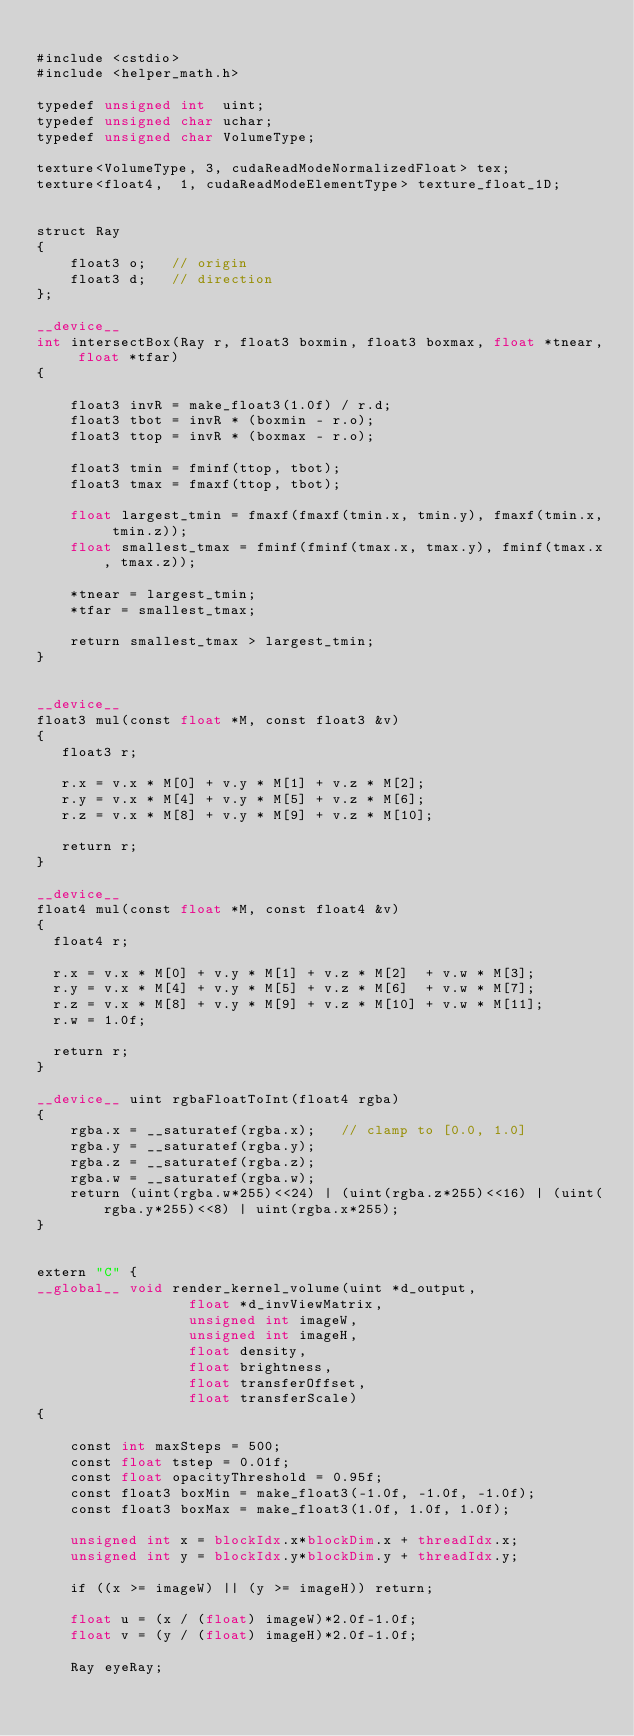Convert code to text. <code><loc_0><loc_0><loc_500><loc_500><_Cuda_>
#include <cstdio>
#include <helper_math.h>

typedef unsigned int  uint;
typedef unsigned char uchar;
typedef unsigned char VolumeType;

texture<VolumeType, 3, cudaReadModeNormalizedFloat> tex;    
texture<float4,  1, cudaReadModeElementType> texture_float_1D;


struct Ray
{
    float3 o;   // origin
    float3 d;   // direction
};

__device__
int intersectBox(Ray r, float3 boxmin, float3 boxmax, float *tnear, float *tfar)
{

    float3 invR = make_float3(1.0f) / r.d;
    float3 tbot = invR * (boxmin - r.o);
    float3 ttop = invR * (boxmax - r.o);

    float3 tmin = fminf(ttop, tbot);
    float3 tmax = fmaxf(ttop, tbot);

    float largest_tmin = fmaxf(fmaxf(tmin.x, tmin.y), fmaxf(tmin.x, tmin.z));
    float smallest_tmax = fminf(fminf(tmax.x, tmax.y), fminf(tmax.x, tmax.z));

    *tnear = largest_tmin;
    *tfar = smallest_tmax;

    return smallest_tmax > largest_tmin;
}


__device__
float3 mul(const float *M, const float3 &v)
{
   float3 r;
   
   r.x = v.x * M[0] + v.y * M[1] + v.z * M[2];
   r.y = v.x * M[4] + v.y * M[5] + v.z * M[6];
   r.z = v.x * M[8] + v.y * M[9] + v.z * M[10];
   
   return r;
}

__device__
float4 mul(const float *M, const float4 &v)
{
	float4 r;

	r.x = v.x * M[0] + v.y * M[1] + v.z * M[2]  + v.w * M[3];
	r.y = v.x * M[4] + v.y * M[5] + v.z * M[6]  + v.w * M[7];
	r.z = v.x * M[8] + v.y * M[9] + v.z * M[10] + v.w * M[11];	
	r.w = 1.0f;
	
	return r;
}

__device__ uint rgbaFloatToInt(float4 rgba)
{
    rgba.x = __saturatef(rgba.x);   // clamp to [0.0, 1.0]
    rgba.y = __saturatef(rgba.y);
    rgba.z = __saturatef(rgba.z);
    rgba.w = __saturatef(rgba.w);
    return (uint(rgba.w*255)<<24) | (uint(rgba.z*255)<<16) | (uint(rgba.y*255)<<8) | uint(rgba.x*255);
}


extern "C" {
__global__ void render_kernel_volume(uint *d_output, 
								  float *d_invViewMatrix, 
								  unsigned int imageW,
								  unsigned int imageH,
								  float density,
								  float brightness,
								  float transferOffset,
								  float transferScale) 
{
	
		const int maxSteps = 500;
		const float tstep = 0.01f;
		const float opacityThreshold = 0.95f;
		const float3 boxMin = make_float3(-1.0f, -1.0f, -1.0f);
		const float3 boxMax = make_float3(1.0f, 1.0f, 1.0f);
	 
		unsigned int x = blockIdx.x*blockDim.x + threadIdx.x;
		unsigned int y = blockIdx.y*blockDim.y + threadIdx.y;
	 
		if ((x >= imageW) || (y >= imageH)) return;
	 
		float u = (x / (float) imageW)*2.0f-1.0f;
		float v = (y / (float) imageH)*2.0f-1.0f;
	 
		Ray eyeRay;</code> 